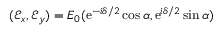<formula> <loc_0><loc_0><loc_500><loc_500>( { \mathcal { E } } _ { x } , { \mathcal { E } } _ { y } ) = E _ { 0 } ( e ^ { - i \delta / 2 } \cos \alpha , e ^ { i \delta / 2 } \sin \alpha )</formula> 